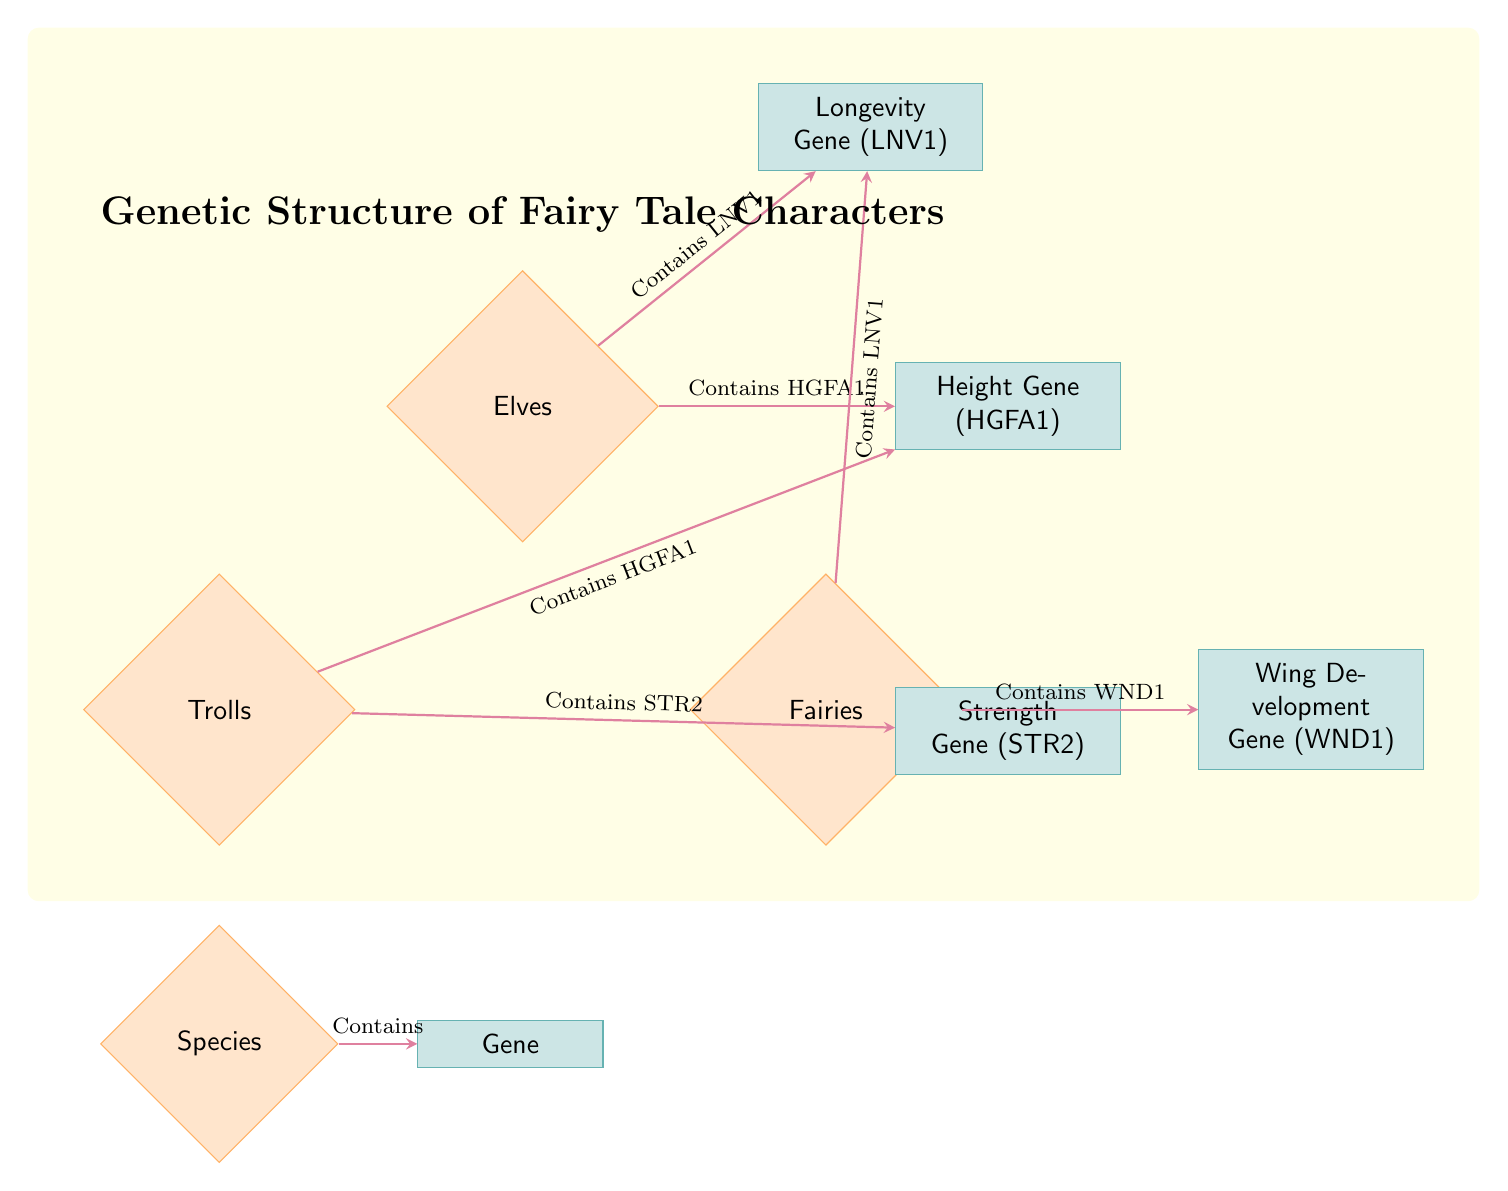What species contains the Height Gene? The Height Gene is linked with both Elves and Trolls in the diagram. The line from Elves and the line from Trolls both indicate that they contain the Height Gene.
Answer: Elves, Trolls How many species are represented in the diagram? The diagram shows three species: Elves, Trolls, and Fairies. Counting each species node confirms there are three.
Answer: 3 Which gene is associated with Fairies? The diagram shows the Wing Development Gene connected to Fairies. The line from Fairies points directly to this gene.
Answer: Wing Development Gene (WND1) What gene do Trolls share with Elves? Both Trolls and Elves have a connection to the Height Gene, indicated by the paths stemming from both species nodes towards Height Gene.
Answer: Height Gene (HGFA1) How many genes are mentioned in the diagram? The diagram lists four genes: Height Gene, Longevity Gene, Strength Gene, and Wing Development Gene. Counting all gene nodes leads to this total.
Answer: 4 Which gene contains the Longevity Gene? Elves and Fairies both contain the Longevity Gene as indicated by the lines connecting these species nodes to the Longevity Gene.
Answer: Longevity Gene (LNV1) What relationship connects Strength Gene to Trolls? The diagram indicates that Trolls contain the Strength Gene, shown by the directional line leading from the Trolls node to the Strength Gene node.
Answer: Contains STR2 Which species are indicated to have the Longevity Gene? The Longevity Gene is connected to both Elves and Fairies via arrows from both species, showing that they both possess this gene.
Answer: Elves, Fairies 